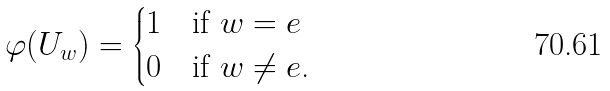<formula> <loc_0><loc_0><loc_500><loc_500>\varphi ( U _ { w } ) = \begin{cases} 1 & \text {if $w=e$} \\ 0 & \text {if $w\neq e$.} \end{cases}</formula> 